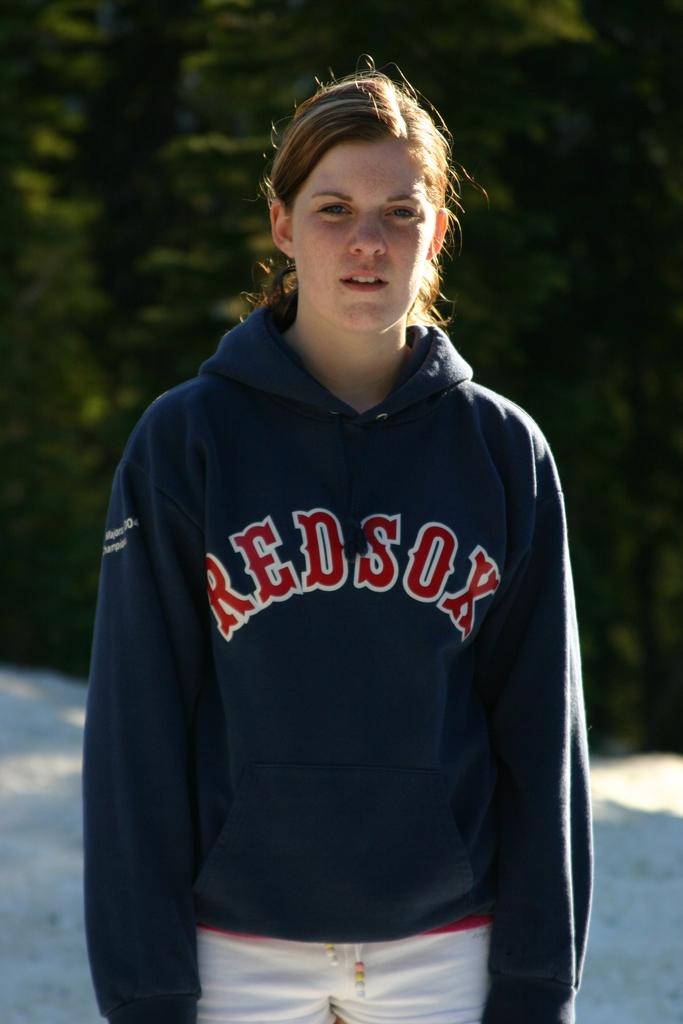What team is she promoting?
Offer a terse response. Redsox. 